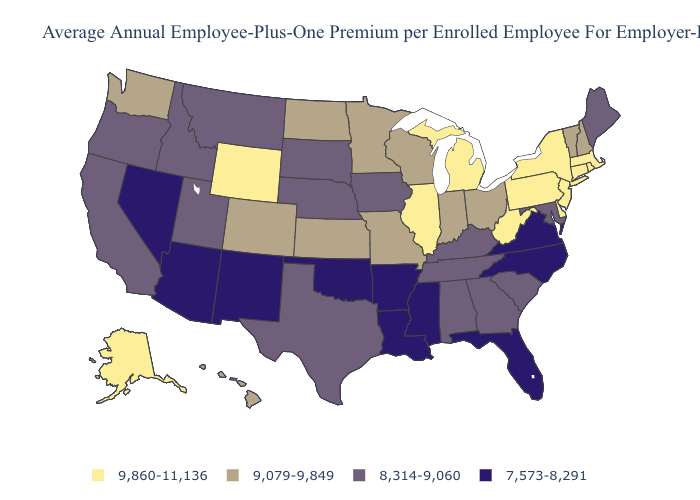What is the value of Illinois?
Be succinct. 9,860-11,136. Name the states that have a value in the range 9,860-11,136?
Give a very brief answer. Alaska, Connecticut, Delaware, Illinois, Massachusetts, Michigan, New Jersey, New York, Pennsylvania, Rhode Island, West Virginia, Wyoming. Does New York have the same value as Missouri?
Answer briefly. No. Among the states that border Michigan , which have the lowest value?
Concise answer only. Indiana, Ohio, Wisconsin. What is the value of Mississippi?
Answer briefly. 7,573-8,291. What is the value of West Virginia?
Write a very short answer. 9,860-11,136. Does Indiana have the lowest value in the USA?
Be succinct. No. Does Kansas have the same value as Colorado?
Keep it brief. Yes. What is the value of Tennessee?
Keep it brief. 8,314-9,060. What is the value of Connecticut?
Give a very brief answer. 9,860-11,136. Name the states that have a value in the range 7,573-8,291?
Answer briefly. Arizona, Arkansas, Florida, Louisiana, Mississippi, Nevada, New Mexico, North Carolina, Oklahoma, Virginia. What is the highest value in the MidWest ?
Quick response, please. 9,860-11,136. Name the states that have a value in the range 8,314-9,060?
Quick response, please. Alabama, California, Georgia, Idaho, Iowa, Kentucky, Maine, Maryland, Montana, Nebraska, Oregon, South Carolina, South Dakota, Tennessee, Texas, Utah. Does New Jersey have the highest value in the USA?
Be succinct. Yes. Name the states that have a value in the range 8,314-9,060?
Be succinct. Alabama, California, Georgia, Idaho, Iowa, Kentucky, Maine, Maryland, Montana, Nebraska, Oregon, South Carolina, South Dakota, Tennessee, Texas, Utah. 